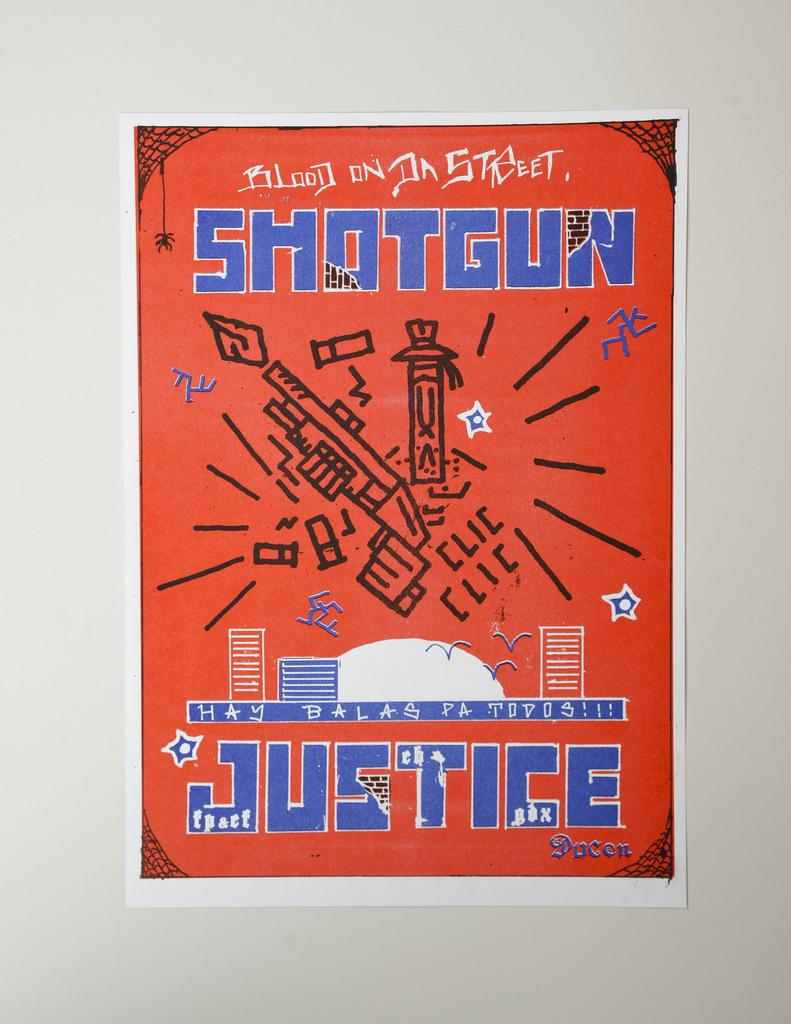<image>
Give a short and clear explanation of the subsequent image. A orange book cover with the title Shotgun Justice. 